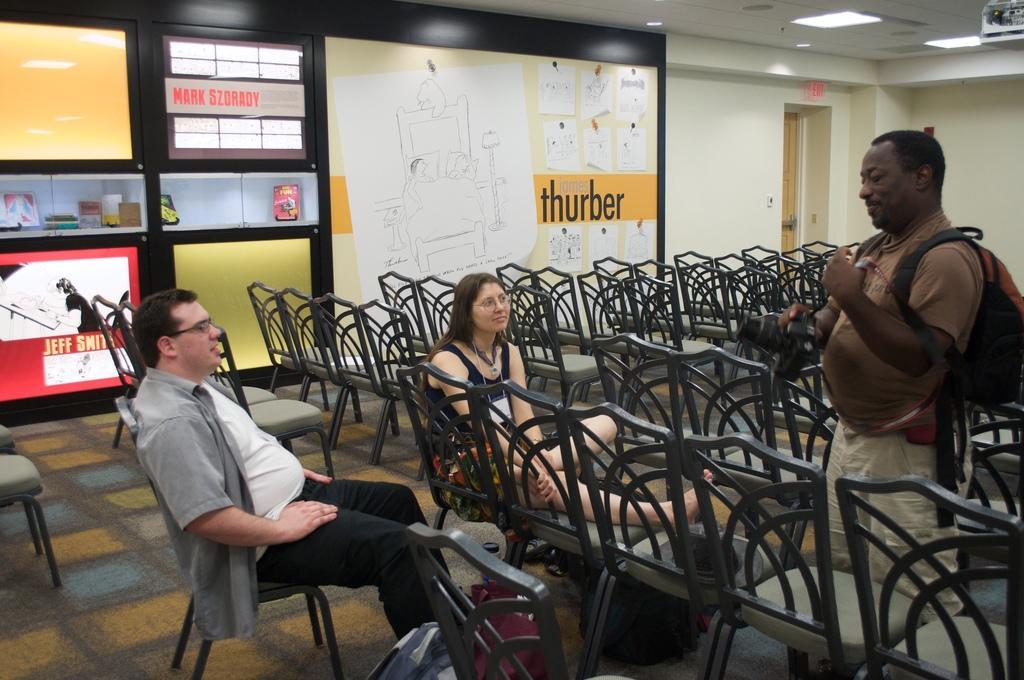Could you give a brief overview of what you see in this image? In this image I can see there are the number of chairs kept on the floor and there are two persons sitting on the chairs and one person standing in front of the chairs and there is a wall visible on the right side. and there is a light on the roof visible. And there is a door on the right side. 